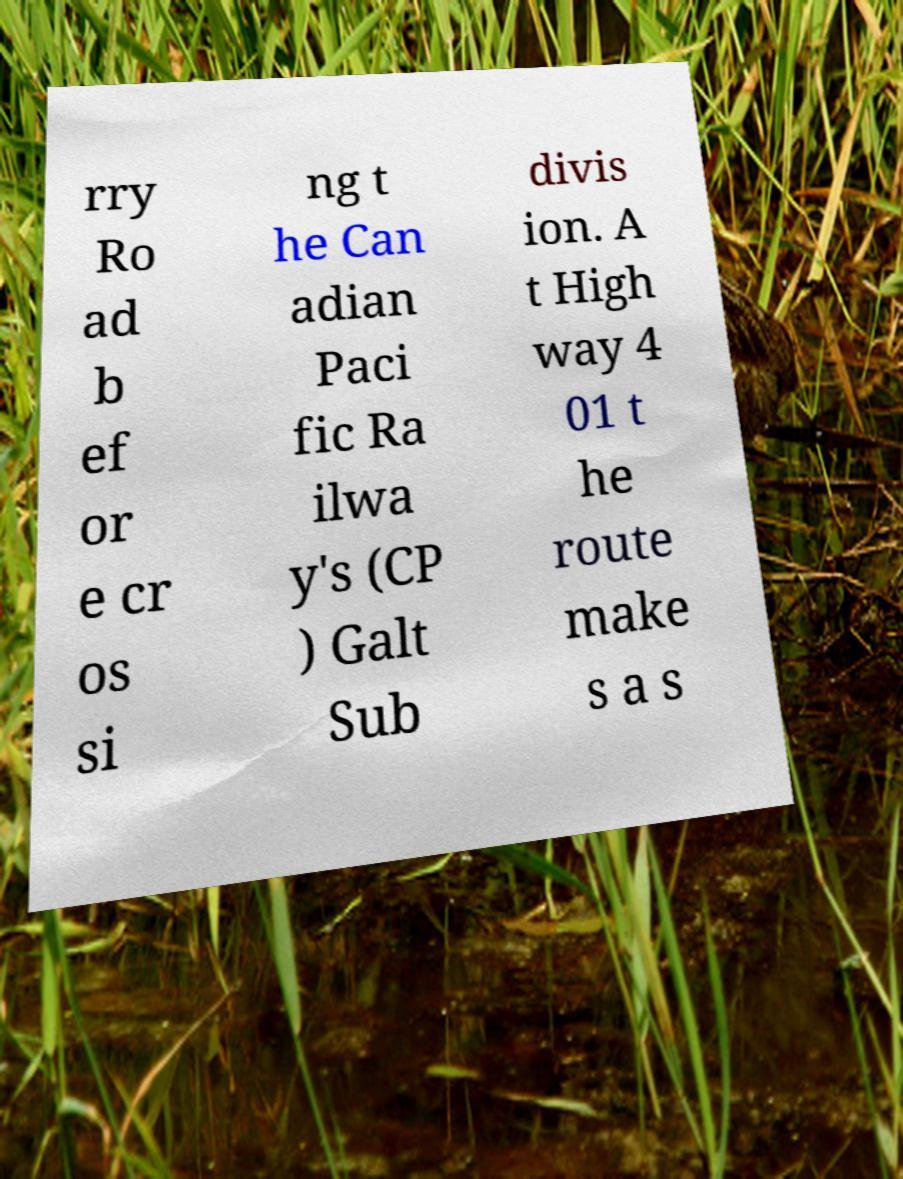Could you extract and type out the text from this image? rry Ro ad b ef or e cr os si ng t he Can adian Paci fic Ra ilwa y's (CP ) Galt Sub divis ion. A t High way 4 01 t he route make s a s 